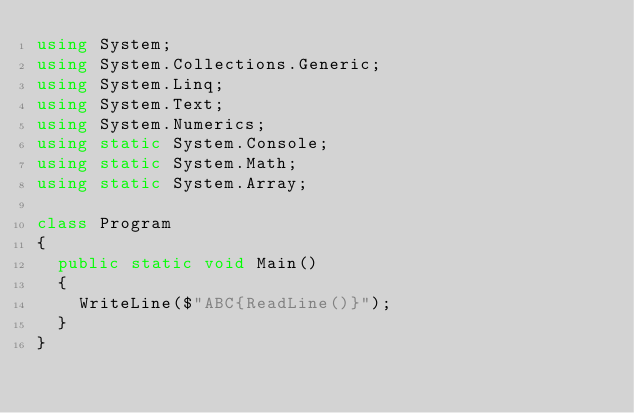<code> <loc_0><loc_0><loc_500><loc_500><_C#_>using System;
using System.Collections.Generic;
using System.Linq;
using System.Text;
using System.Numerics;
using static System.Console;
using static System.Math;
using static System.Array;

class Program
{
	public static void Main()
	{
		WriteLine($"ABC{ReadLine()}");
	}
}
</code> 